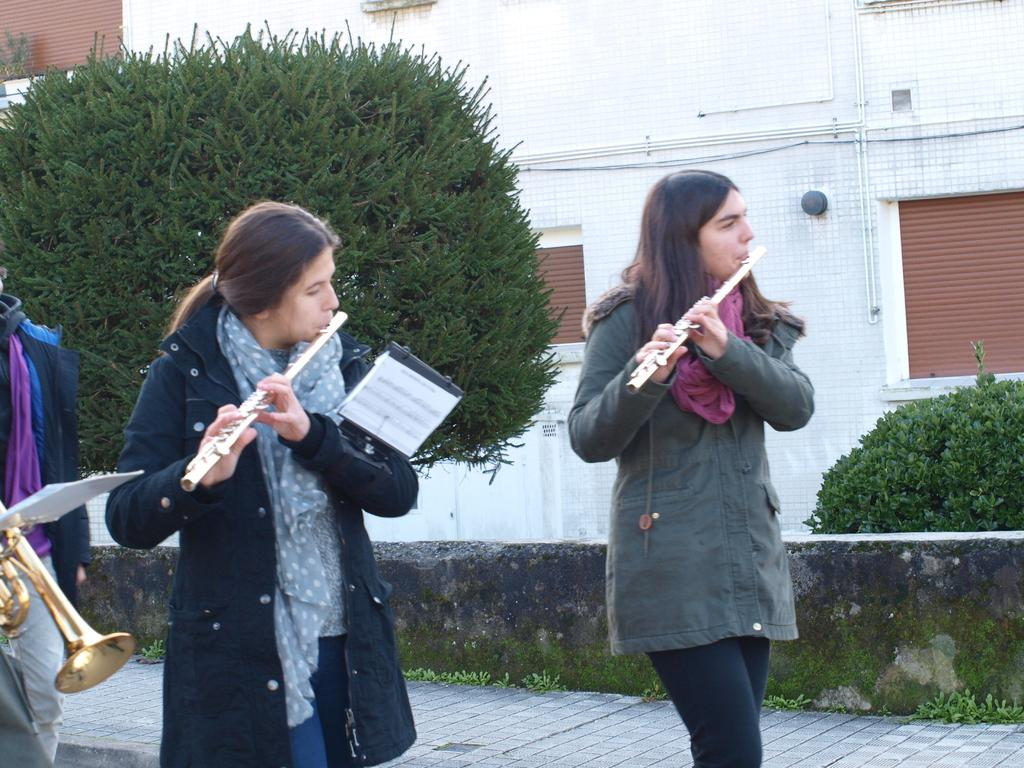How many women are in the image? There are two women in the image. What are the women doing in the image? The women are standing and holding flutes. Can you describe the person in the image? There is a person in the image, but no specific details are provided. What can be seen in the background of the image? There are plants and a wall in the background of the image. What type of string is being used to join the two women together in the image? There is no string or any indication of the women being joined together in the image. 